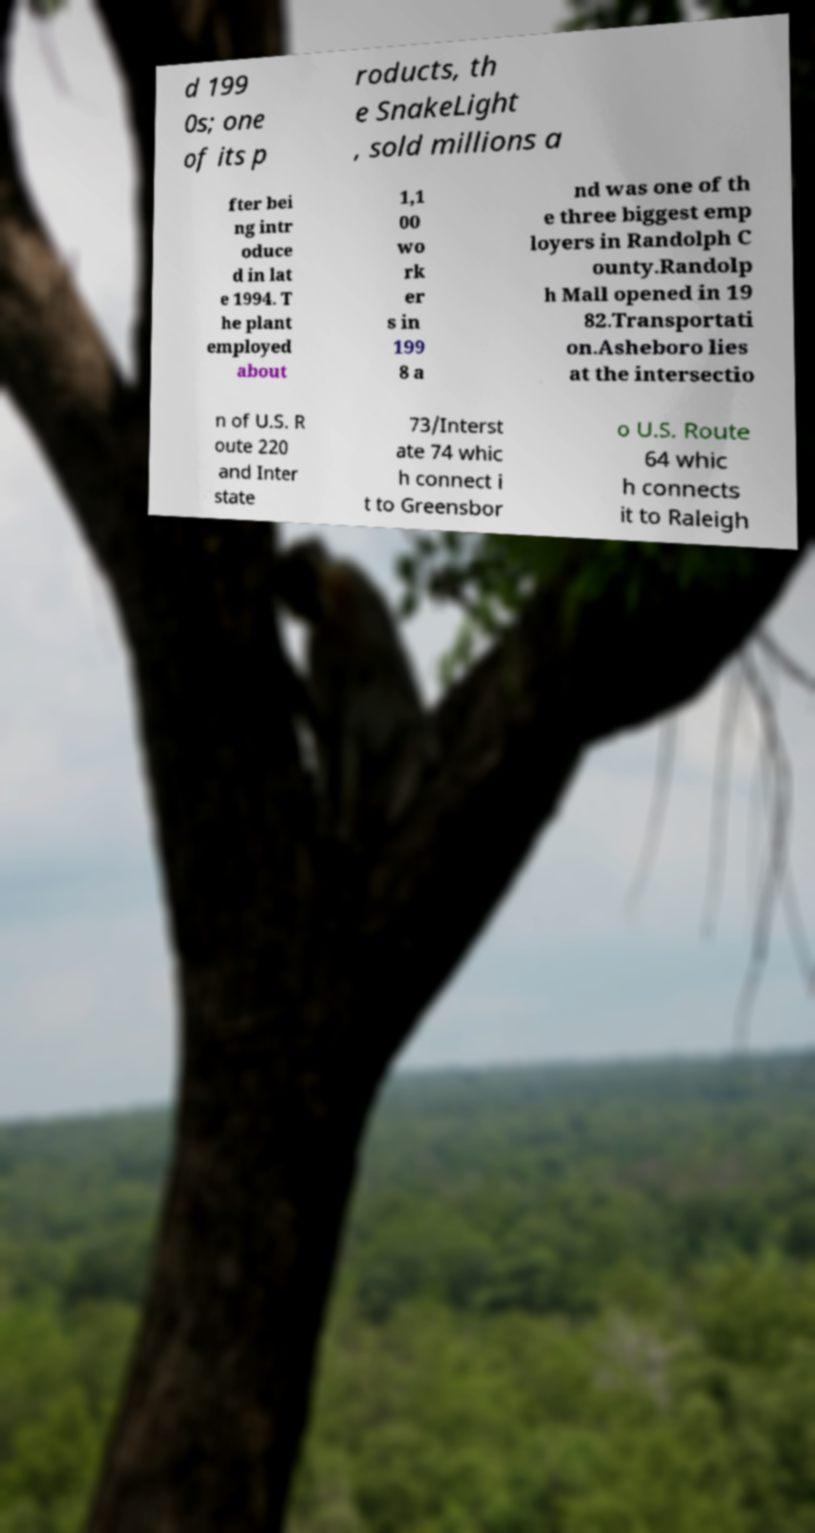Could you extract and type out the text from this image? d 199 0s; one of its p roducts, th e SnakeLight , sold millions a fter bei ng intr oduce d in lat e 1994. T he plant employed about 1,1 00 wo rk er s in 199 8 a nd was one of th e three biggest emp loyers in Randolph C ounty.Randolp h Mall opened in 19 82.Transportati on.Asheboro lies at the intersectio n of U.S. R oute 220 and Inter state 73/Interst ate 74 whic h connect i t to Greensbor o U.S. Route 64 whic h connects it to Raleigh 